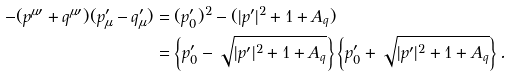Convert formula to latex. <formula><loc_0><loc_0><loc_500><loc_500>- ( p ^ { \mu \prime } + q ^ { \mu \prime } ) ( p _ { \mu } ^ { \prime } - q _ { \mu } ^ { \prime } ) & = ( p _ { 0 } ^ { \prime } ) ^ { 2 } - ( | p ^ { \prime } | ^ { 2 } + 1 + A _ { q } ) \\ & = \left \{ p _ { 0 } ^ { \prime } - \sqrt { | p ^ { \prime } | ^ { 2 } + 1 + A _ { q } } \right \} \left \{ p _ { 0 } ^ { \prime } + \sqrt { | p ^ { \prime } | ^ { 2 } + 1 + A _ { q } } \right \} .</formula> 